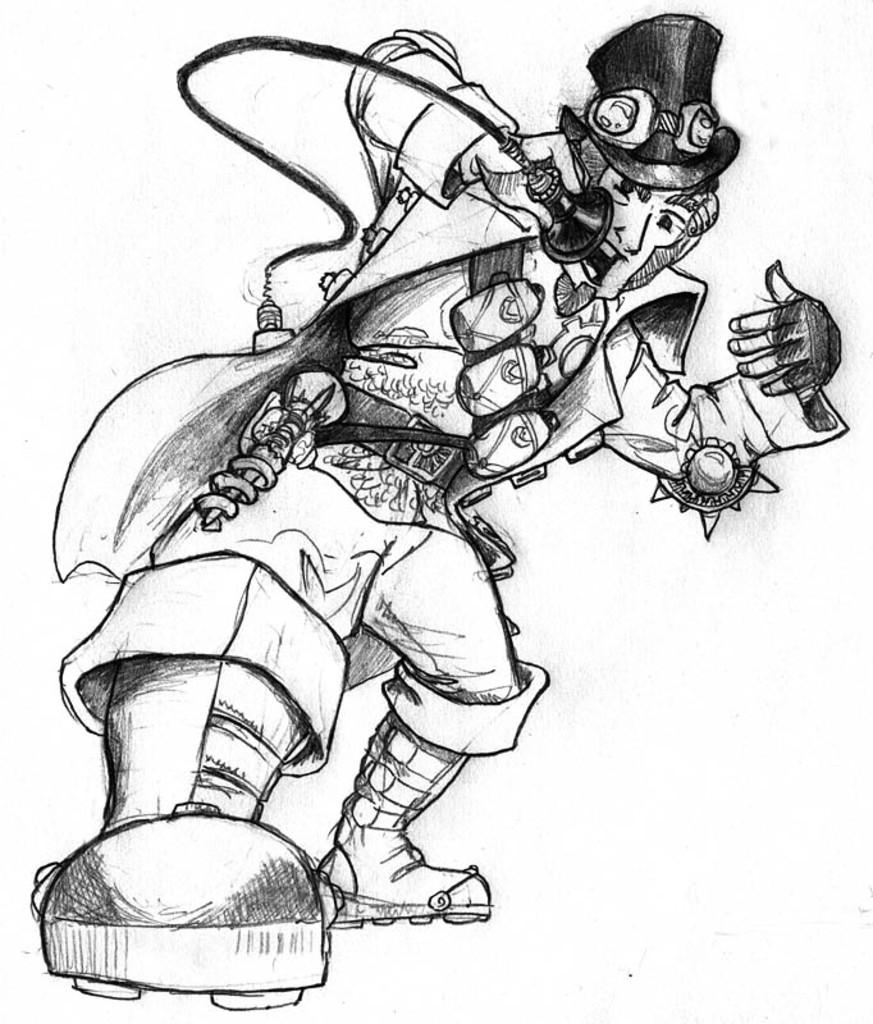What is the main subject of the image? The main subject of the image is a sketch of a person. What is the person holding in their hand? The person is holding an object in their hand. Can you describe the color of the object? The object is in black color. What is the color of the background in the image? The background of the image is white. What type of vegetable can be seen growing in the background of the image? There is no vegetable present in the image, as the background is white. Is there a comb visible in the person's hair in the image? There is no comb visible in the person's hair in the image, as the sketch only shows the person holding an object. 